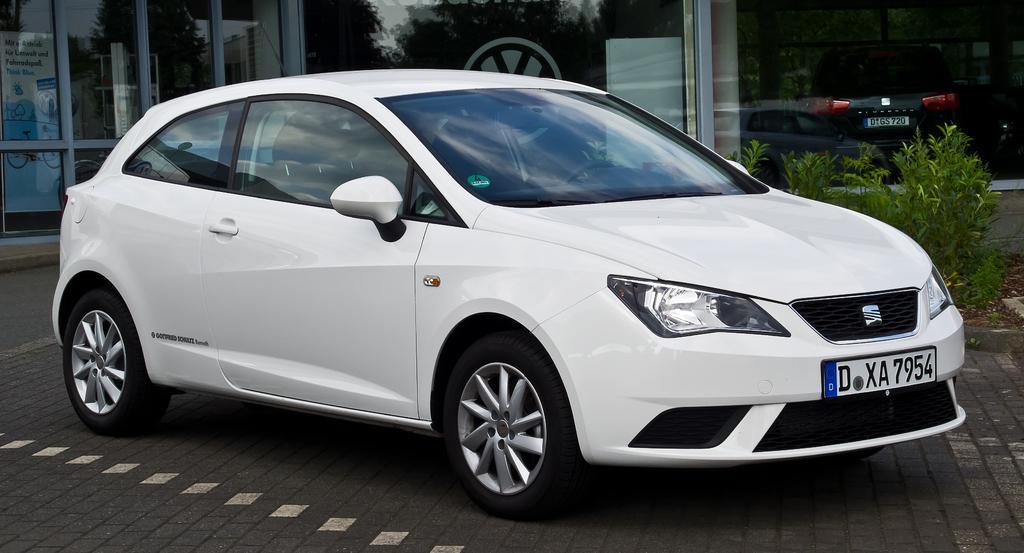How would you summarize this image in a sentence or two? In this image there is a car on the road, there are a few plants and few glass doors, inside the glass doors there is a vehicle, banner and reflection of few trees. 